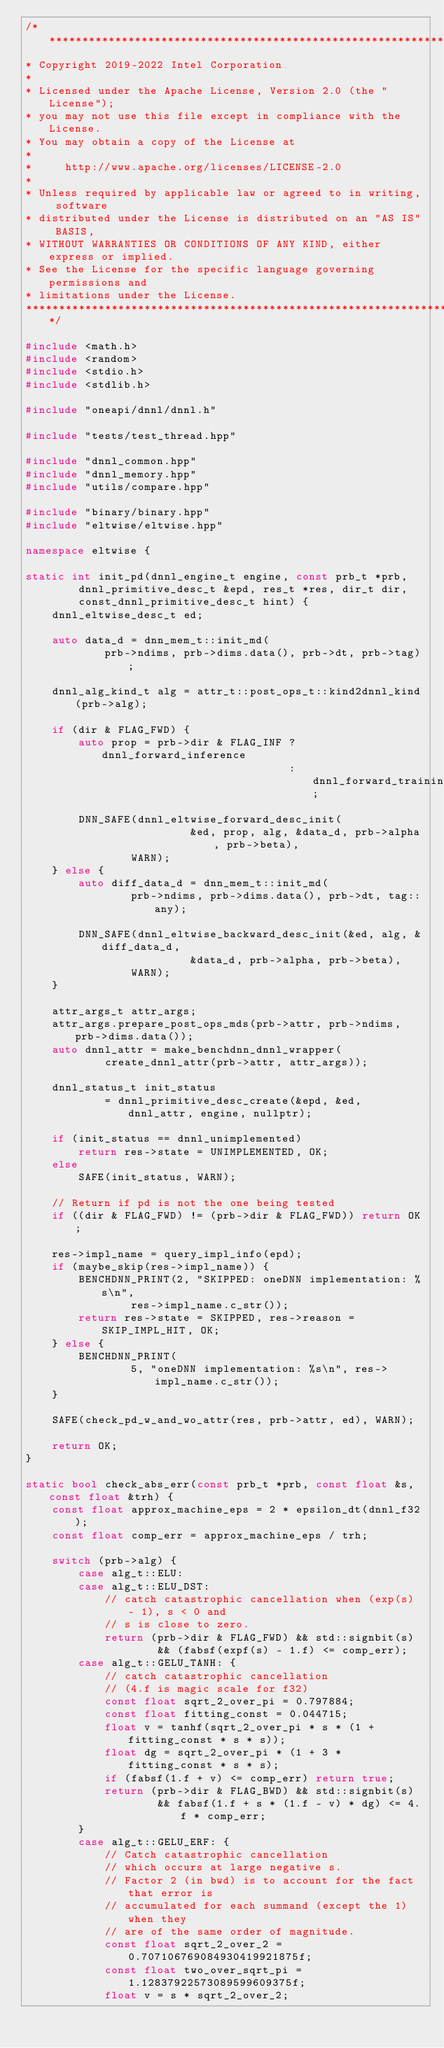<code> <loc_0><loc_0><loc_500><loc_500><_C++_>/*******************************************************************************
* Copyright 2019-2022 Intel Corporation
*
* Licensed under the Apache License, Version 2.0 (the "License");
* you may not use this file except in compliance with the License.
* You may obtain a copy of the License at
*
*     http://www.apache.org/licenses/LICENSE-2.0
*
* Unless required by applicable law or agreed to in writing, software
* distributed under the License is distributed on an "AS IS" BASIS,
* WITHOUT WARRANTIES OR CONDITIONS OF ANY KIND, either express or implied.
* See the License for the specific language governing permissions and
* limitations under the License.
*******************************************************************************/

#include <math.h>
#include <random>
#include <stdio.h>
#include <stdlib.h>

#include "oneapi/dnnl/dnnl.h"

#include "tests/test_thread.hpp"

#include "dnnl_common.hpp"
#include "dnnl_memory.hpp"
#include "utils/compare.hpp"

#include "binary/binary.hpp"
#include "eltwise/eltwise.hpp"

namespace eltwise {

static int init_pd(dnnl_engine_t engine, const prb_t *prb,
        dnnl_primitive_desc_t &epd, res_t *res, dir_t dir,
        const_dnnl_primitive_desc_t hint) {
    dnnl_eltwise_desc_t ed;

    auto data_d = dnn_mem_t::init_md(
            prb->ndims, prb->dims.data(), prb->dt, prb->tag);

    dnnl_alg_kind_t alg = attr_t::post_ops_t::kind2dnnl_kind(prb->alg);

    if (dir & FLAG_FWD) {
        auto prop = prb->dir & FLAG_INF ? dnnl_forward_inference
                                        : dnnl_forward_training;

        DNN_SAFE(dnnl_eltwise_forward_desc_init(
                         &ed, prop, alg, &data_d, prb->alpha, prb->beta),
                WARN);
    } else {
        auto diff_data_d = dnn_mem_t::init_md(
                prb->ndims, prb->dims.data(), prb->dt, tag::any);

        DNN_SAFE(dnnl_eltwise_backward_desc_init(&ed, alg, &diff_data_d,
                         &data_d, prb->alpha, prb->beta),
                WARN);
    }

    attr_args_t attr_args;
    attr_args.prepare_post_ops_mds(prb->attr, prb->ndims, prb->dims.data());
    auto dnnl_attr = make_benchdnn_dnnl_wrapper(
            create_dnnl_attr(prb->attr, attr_args));

    dnnl_status_t init_status
            = dnnl_primitive_desc_create(&epd, &ed, dnnl_attr, engine, nullptr);

    if (init_status == dnnl_unimplemented)
        return res->state = UNIMPLEMENTED, OK;
    else
        SAFE(init_status, WARN);

    // Return if pd is not the one being tested
    if ((dir & FLAG_FWD) != (prb->dir & FLAG_FWD)) return OK;

    res->impl_name = query_impl_info(epd);
    if (maybe_skip(res->impl_name)) {
        BENCHDNN_PRINT(2, "SKIPPED: oneDNN implementation: %s\n",
                res->impl_name.c_str());
        return res->state = SKIPPED, res->reason = SKIP_IMPL_HIT, OK;
    } else {
        BENCHDNN_PRINT(
                5, "oneDNN implementation: %s\n", res->impl_name.c_str());
    }

    SAFE(check_pd_w_and_wo_attr(res, prb->attr, ed), WARN);

    return OK;
}

static bool check_abs_err(const prb_t *prb, const float &s, const float &trh) {
    const float approx_machine_eps = 2 * epsilon_dt(dnnl_f32);
    const float comp_err = approx_machine_eps / trh;

    switch (prb->alg) {
        case alg_t::ELU:
        case alg_t::ELU_DST:
            // catch catastrophic cancellation when (exp(s) - 1), s < 0 and
            // s is close to zero.
            return (prb->dir & FLAG_FWD) && std::signbit(s)
                    && (fabsf(expf(s) - 1.f) <= comp_err);
        case alg_t::GELU_TANH: {
            // catch catastrophic cancellation
            // (4.f is magic scale for f32)
            const float sqrt_2_over_pi = 0.797884;
            const float fitting_const = 0.044715;
            float v = tanhf(sqrt_2_over_pi * s * (1 + fitting_const * s * s));
            float dg = sqrt_2_over_pi * (1 + 3 * fitting_const * s * s);
            if (fabsf(1.f + v) <= comp_err) return true;
            return (prb->dir & FLAG_BWD) && std::signbit(s)
                    && fabsf(1.f + s * (1.f - v) * dg) <= 4.f * comp_err;
        }
        case alg_t::GELU_ERF: {
            // Catch catastrophic cancellation
            // which occurs at large negative s.
            // Factor 2 (in bwd) is to account for the fact that error is
            // accumulated for each summand (except the 1) when they
            // are of the same order of magnitude.
            const float sqrt_2_over_2 = 0.707106769084930419921875f;
            const float two_over_sqrt_pi = 1.12837922573089599609375f;
            float v = s * sqrt_2_over_2;</code> 